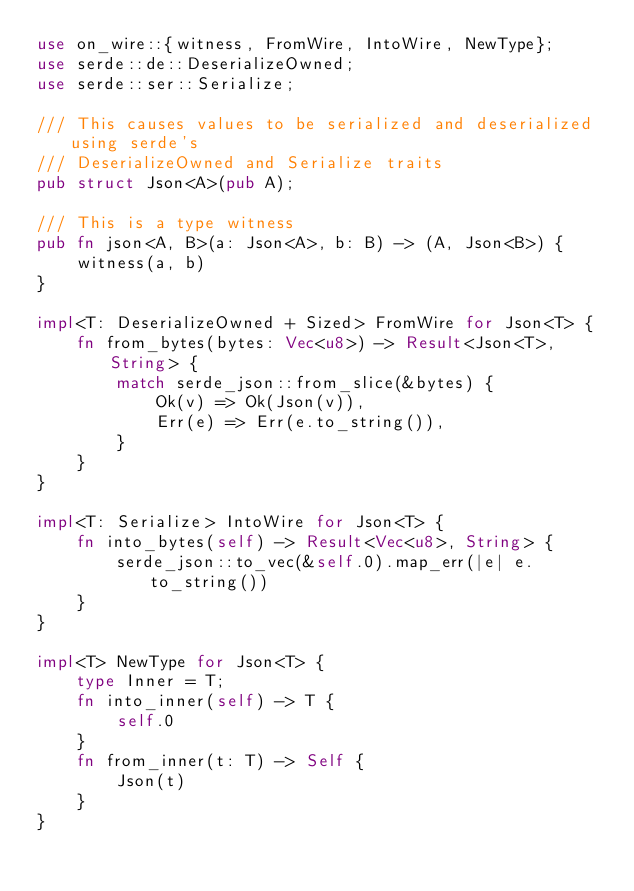Convert code to text. <code><loc_0><loc_0><loc_500><loc_500><_Rust_>use on_wire::{witness, FromWire, IntoWire, NewType};
use serde::de::DeserializeOwned;
use serde::ser::Serialize;

/// This causes values to be serialized and deserialized using serde's
/// DeserializeOwned and Serialize traits
pub struct Json<A>(pub A);

/// This is a type witness
pub fn json<A, B>(a: Json<A>, b: B) -> (A, Json<B>) {
    witness(a, b)
}

impl<T: DeserializeOwned + Sized> FromWire for Json<T> {
    fn from_bytes(bytes: Vec<u8>) -> Result<Json<T>, String> {
        match serde_json::from_slice(&bytes) {
            Ok(v) => Ok(Json(v)),
            Err(e) => Err(e.to_string()),
        }
    }
}

impl<T: Serialize> IntoWire for Json<T> {
    fn into_bytes(self) -> Result<Vec<u8>, String> {
        serde_json::to_vec(&self.0).map_err(|e| e.to_string())
    }
}

impl<T> NewType for Json<T> {
    type Inner = T;
    fn into_inner(self) -> T {
        self.0
    }
    fn from_inner(t: T) -> Self {
        Json(t)
    }
}
</code> 